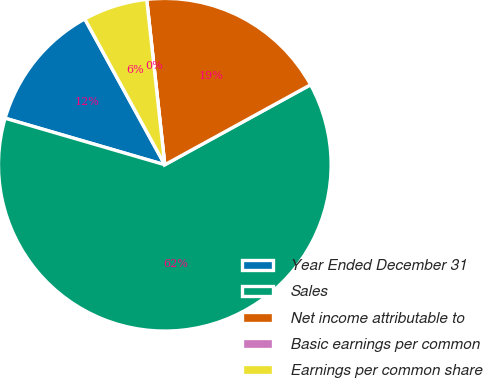Convert chart to OTSL. <chart><loc_0><loc_0><loc_500><loc_500><pie_chart><fcel>Year Ended December 31<fcel>Sales<fcel>Net income attributable to<fcel>Basic earnings per common<fcel>Earnings per common share<nl><fcel>12.5%<fcel>62.5%<fcel>18.75%<fcel>0.0%<fcel>6.25%<nl></chart> 